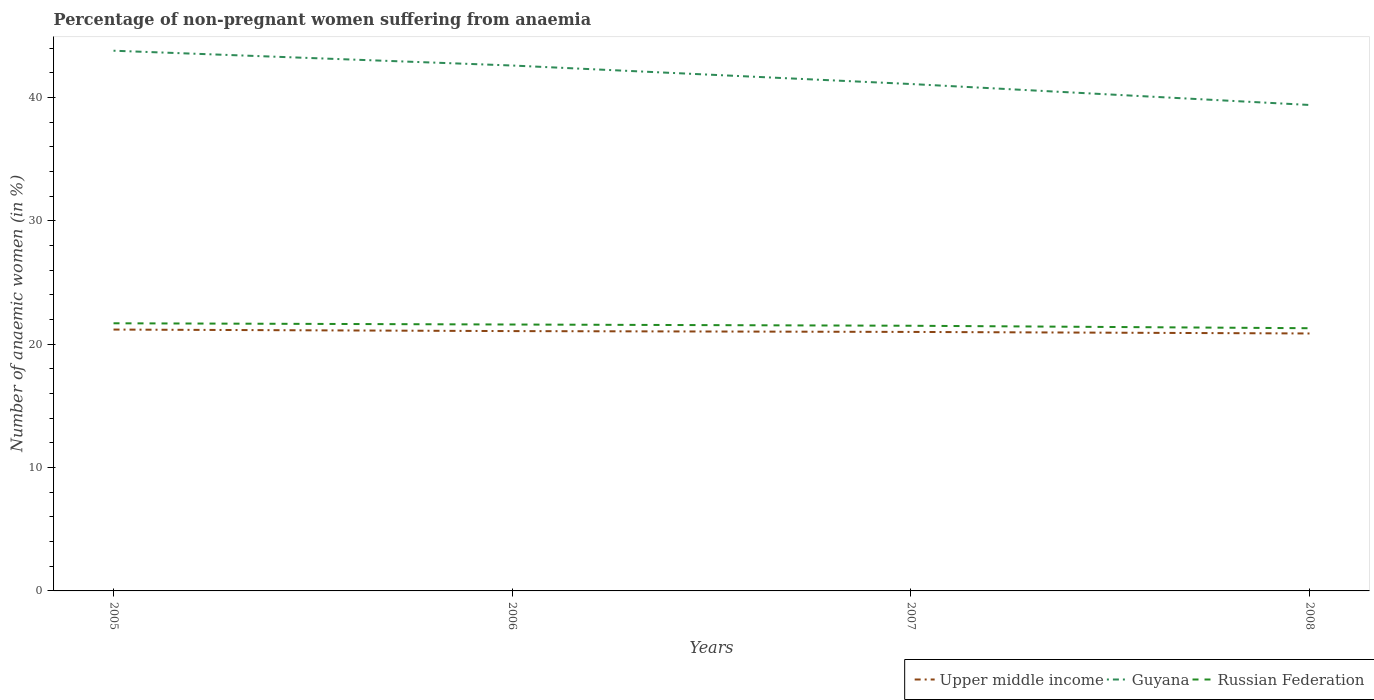How many different coloured lines are there?
Ensure brevity in your answer.  3. Is the number of lines equal to the number of legend labels?
Provide a short and direct response. Yes. Across all years, what is the maximum percentage of non-pregnant women suffering from anaemia in Guyana?
Give a very brief answer. 39.4. In which year was the percentage of non-pregnant women suffering from anaemia in Upper middle income maximum?
Your answer should be very brief. 2008. What is the total percentage of non-pregnant women suffering from anaemia in Russian Federation in the graph?
Provide a succinct answer. 0.1. What is the difference between the highest and the second highest percentage of non-pregnant women suffering from anaemia in Upper middle income?
Your answer should be very brief. 0.32. How many lines are there?
Make the answer very short. 3. How many years are there in the graph?
Your answer should be compact. 4. Does the graph contain any zero values?
Give a very brief answer. No. How are the legend labels stacked?
Offer a terse response. Horizontal. What is the title of the graph?
Offer a very short reply. Percentage of non-pregnant women suffering from anaemia. What is the label or title of the X-axis?
Provide a short and direct response. Years. What is the label or title of the Y-axis?
Offer a terse response. Number of anaemic women (in %). What is the Number of anaemic women (in %) in Upper middle income in 2005?
Your response must be concise. 21.19. What is the Number of anaemic women (in %) of Guyana in 2005?
Keep it short and to the point. 43.8. What is the Number of anaemic women (in %) of Russian Federation in 2005?
Your response must be concise. 21.7. What is the Number of anaemic women (in %) of Upper middle income in 2006?
Your answer should be compact. 21.07. What is the Number of anaemic women (in %) in Guyana in 2006?
Provide a short and direct response. 42.6. What is the Number of anaemic women (in %) of Russian Federation in 2006?
Provide a short and direct response. 21.6. What is the Number of anaemic women (in %) of Upper middle income in 2007?
Keep it short and to the point. 21. What is the Number of anaemic women (in %) in Guyana in 2007?
Provide a short and direct response. 41.1. What is the Number of anaemic women (in %) of Upper middle income in 2008?
Your answer should be very brief. 20.87. What is the Number of anaemic women (in %) of Guyana in 2008?
Provide a succinct answer. 39.4. What is the Number of anaemic women (in %) of Russian Federation in 2008?
Offer a very short reply. 21.3. Across all years, what is the maximum Number of anaemic women (in %) of Upper middle income?
Ensure brevity in your answer.  21.19. Across all years, what is the maximum Number of anaemic women (in %) in Guyana?
Give a very brief answer. 43.8. Across all years, what is the maximum Number of anaemic women (in %) in Russian Federation?
Provide a short and direct response. 21.7. Across all years, what is the minimum Number of anaemic women (in %) of Upper middle income?
Keep it short and to the point. 20.87. Across all years, what is the minimum Number of anaemic women (in %) in Guyana?
Your answer should be very brief. 39.4. Across all years, what is the minimum Number of anaemic women (in %) of Russian Federation?
Your answer should be very brief. 21.3. What is the total Number of anaemic women (in %) in Upper middle income in the graph?
Provide a short and direct response. 84.13. What is the total Number of anaemic women (in %) of Guyana in the graph?
Offer a terse response. 166.9. What is the total Number of anaemic women (in %) in Russian Federation in the graph?
Your answer should be compact. 86.1. What is the difference between the Number of anaemic women (in %) of Upper middle income in 2005 and that in 2006?
Your response must be concise. 0.12. What is the difference between the Number of anaemic women (in %) in Russian Federation in 2005 and that in 2006?
Make the answer very short. 0.1. What is the difference between the Number of anaemic women (in %) of Upper middle income in 2005 and that in 2007?
Ensure brevity in your answer.  0.19. What is the difference between the Number of anaemic women (in %) of Russian Federation in 2005 and that in 2007?
Your answer should be very brief. 0.2. What is the difference between the Number of anaemic women (in %) in Upper middle income in 2005 and that in 2008?
Your answer should be very brief. 0.32. What is the difference between the Number of anaemic women (in %) of Russian Federation in 2005 and that in 2008?
Offer a very short reply. 0.4. What is the difference between the Number of anaemic women (in %) in Upper middle income in 2006 and that in 2007?
Your response must be concise. 0.07. What is the difference between the Number of anaemic women (in %) in Russian Federation in 2006 and that in 2007?
Give a very brief answer. 0.1. What is the difference between the Number of anaemic women (in %) in Upper middle income in 2006 and that in 2008?
Offer a very short reply. 0.19. What is the difference between the Number of anaemic women (in %) in Russian Federation in 2006 and that in 2008?
Your response must be concise. 0.3. What is the difference between the Number of anaemic women (in %) of Upper middle income in 2007 and that in 2008?
Offer a terse response. 0.13. What is the difference between the Number of anaemic women (in %) in Guyana in 2007 and that in 2008?
Your response must be concise. 1.7. What is the difference between the Number of anaemic women (in %) in Upper middle income in 2005 and the Number of anaemic women (in %) in Guyana in 2006?
Your answer should be compact. -21.41. What is the difference between the Number of anaemic women (in %) of Upper middle income in 2005 and the Number of anaemic women (in %) of Russian Federation in 2006?
Your answer should be very brief. -0.41. What is the difference between the Number of anaemic women (in %) of Guyana in 2005 and the Number of anaemic women (in %) of Russian Federation in 2006?
Offer a terse response. 22.2. What is the difference between the Number of anaemic women (in %) of Upper middle income in 2005 and the Number of anaemic women (in %) of Guyana in 2007?
Your answer should be compact. -19.91. What is the difference between the Number of anaemic women (in %) in Upper middle income in 2005 and the Number of anaemic women (in %) in Russian Federation in 2007?
Your answer should be very brief. -0.31. What is the difference between the Number of anaemic women (in %) in Guyana in 2005 and the Number of anaemic women (in %) in Russian Federation in 2007?
Your answer should be compact. 22.3. What is the difference between the Number of anaemic women (in %) in Upper middle income in 2005 and the Number of anaemic women (in %) in Guyana in 2008?
Give a very brief answer. -18.21. What is the difference between the Number of anaemic women (in %) of Upper middle income in 2005 and the Number of anaemic women (in %) of Russian Federation in 2008?
Ensure brevity in your answer.  -0.11. What is the difference between the Number of anaemic women (in %) in Upper middle income in 2006 and the Number of anaemic women (in %) in Guyana in 2007?
Your answer should be very brief. -20.03. What is the difference between the Number of anaemic women (in %) in Upper middle income in 2006 and the Number of anaemic women (in %) in Russian Federation in 2007?
Make the answer very short. -0.43. What is the difference between the Number of anaemic women (in %) of Guyana in 2006 and the Number of anaemic women (in %) of Russian Federation in 2007?
Give a very brief answer. 21.1. What is the difference between the Number of anaemic women (in %) in Upper middle income in 2006 and the Number of anaemic women (in %) in Guyana in 2008?
Provide a succinct answer. -18.33. What is the difference between the Number of anaemic women (in %) in Upper middle income in 2006 and the Number of anaemic women (in %) in Russian Federation in 2008?
Provide a succinct answer. -0.23. What is the difference between the Number of anaemic women (in %) of Guyana in 2006 and the Number of anaemic women (in %) of Russian Federation in 2008?
Provide a short and direct response. 21.3. What is the difference between the Number of anaemic women (in %) of Upper middle income in 2007 and the Number of anaemic women (in %) of Guyana in 2008?
Provide a succinct answer. -18.4. What is the difference between the Number of anaemic women (in %) of Upper middle income in 2007 and the Number of anaemic women (in %) of Russian Federation in 2008?
Make the answer very short. -0.3. What is the difference between the Number of anaemic women (in %) of Guyana in 2007 and the Number of anaemic women (in %) of Russian Federation in 2008?
Offer a terse response. 19.8. What is the average Number of anaemic women (in %) in Upper middle income per year?
Offer a very short reply. 21.03. What is the average Number of anaemic women (in %) in Guyana per year?
Ensure brevity in your answer.  41.73. What is the average Number of anaemic women (in %) in Russian Federation per year?
Your answer should be compact. 21.52. In the year 2005, what is the difference between the Number of anaemic women (in %) of Upper middle income and Number of anaemic women (in %) of Guyana?
Make the answer very short. -22.61. In the year 2005, what is the difference between the Number of anaemic women (in %) in Upper middle income and Number of anaemic women (in %) in Russian Federation?
Offer a very short reply. -0.51. In the year 2005, what is the difference between the Number of anaemic women (in %) in Guyana and Number of anaemic women (in %) in Russian Federation?
Make the answer very short. 22.1. In the year 2006, what is the difference between the Number of anaemic women (in %) of Upper middle income and Number of anaemic women (in %) of Guyana?
Ensure brevity in your answer.  -21.53. In the year 2006, what is the difference between the Number of anaemic women (in %) of Upper middle income and Number of anaemic women (in %) of Russian Federation?
Give a very brief answer. -0.53. In the year 2007, what is the difference between the Number of anaemic women (in %) in Upper middle income and Number of anaemic women (in %) in Guyana?
Provide a succinct answer. -20.1. In the year 2007, what is the difference between the Number of anaemic women (in %) of Upper middle income and Number of anaemic women (in %) of Russian Federation?
Your answer should be very brief. -0.5. In the year 2007, what is the difference between the Number of anaemic women (in %) of Guyana and Number of anaemic women (in %) of Russian Federation?
Your answer should be very brief. 19.6. In the year 2008, what is the difference between the Number of anaemic women (in %) of Upper middle income and Number of anaemic women (in %) of Guyana?
Provide a short and direct response. -18.53. In the year 2008, what is the difference between the Number of anaemic women (in %) of Upper middle income and Number of anaemic women (in %) of Russian Federation?
Keep it short and to the point. -0.43. What is the ratio of the Number of anaemic women (in %) in Upper middle income in 2005 to that in 2006?
Your answer should be compact. 1.01. What is the ratio of the Number of anaemic women (in %) in Guyana in 2005 to that in 2006?
Give a very brief answer. 1.03. What is the ratio of the Number of anaemic women (in %) of Upper middle income in 2005 to that in 2007?
Provide a short and direct response. 1.01. What is the ratio of the Number of anaemic women (in %) of Guyana in 2005 to that in 2007?
Your answer should be compact. 1.07. What is the ratio of the Number of anaemic women (in %) of Russian Federation in 2005 to that in 2007?
Ensure brevity in your answer.  1.01. What is the ratio of the Number of anaemic women (in %) of Upper middle income in 2005 to that in 2008?
Give a very brief answer. 1.02. What is the ratio of the Number of anaemic women (in %) in Guyana in 2005 to that in 2008?
Offer a terse response. 1.11. What is the ratio of the Number of anaemic women (in %) of Russian Federation in 2005 to that in 2008?
Make the answer very short. 1.02. What is the ratio of the Number of anaemic women (in %) of Guyana in 2006 to that in 2007?
Your answer should be compact. 1.04. What is the ratio of the Number of anaemic women (in %) of Russian Federation in 2006 to that in 2007?
Ensure brevity in your answer.  1. What is the ratio of the Number of anaemic women (in %) in Upper middle income in 2006 to that in 2008?
Offer a terse response. 1.01. What is the ratio of the Number of anaemic women (in %) of Guyana in 2006 to that in 2008?
Your answer should be very brief. 1.08. What is the ratio of the Number of anaemic women (in %) of Russian Federation in 2006 to that in 2008?
Offer a very short reply. 1.01. What is the ratio of the Number of anaemic women (in %) in Upper middle income in 2007 to that in 2008?
Keep it short and to the point. 1.01. What is the ratio of the Number of anaemic women (in %) of Guyana in 2007 to that in 2008?
Your answer should be very brief. 1.04. What is the ratio of the Number of anaemic women (in %) of Russian Federation in 2007 to that in 2008?
Your answer should be compact. 1.01. What is the difference between the highest and the second highest Number of anaemic women (in %) in Upper middle income?
Ensure brevity in your answer.  0.12. What is the difference between the highest and the second highest Number of anaemic women (in %) in Guyana?
Offer a terse response. 1.2. What is the difference between the highest and the second highest Number of anaemic women (in %) in Russian Federation?
Give a very brief answer. 0.1. What is the difference between the highest and the lowest Number of anaemic women (in %) of Upper middle income?
Provide a short and direct response. 0.32. 